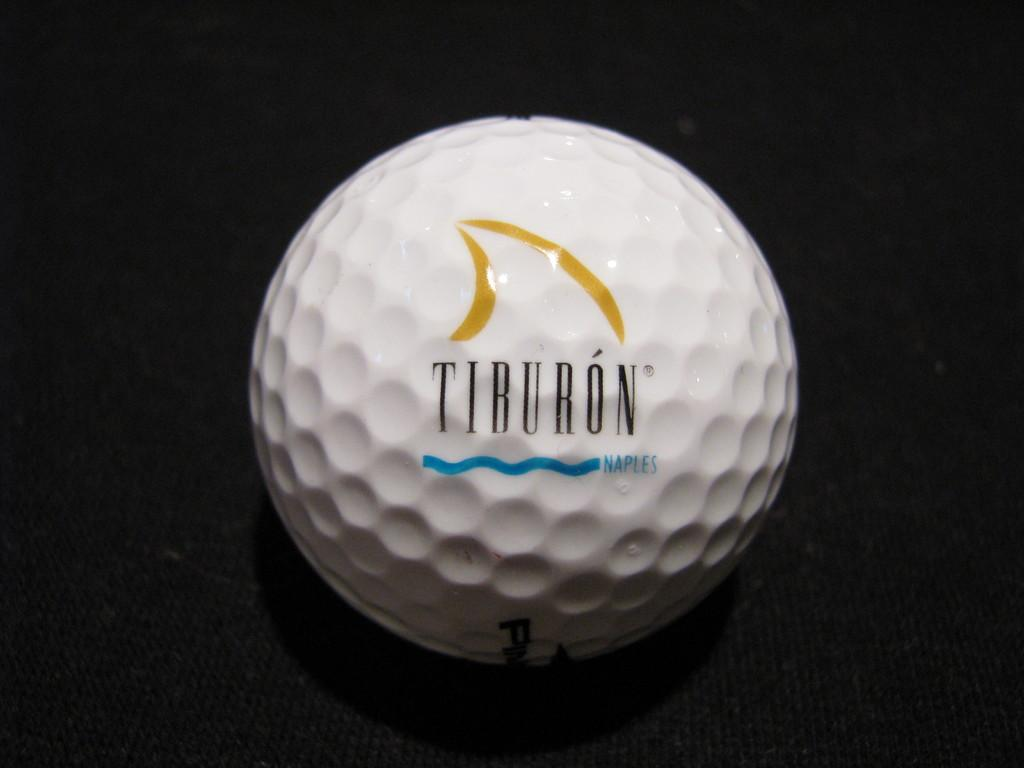<image>
Describe the image concisely. A Tiburon golf ball is surrounded by blackness. 